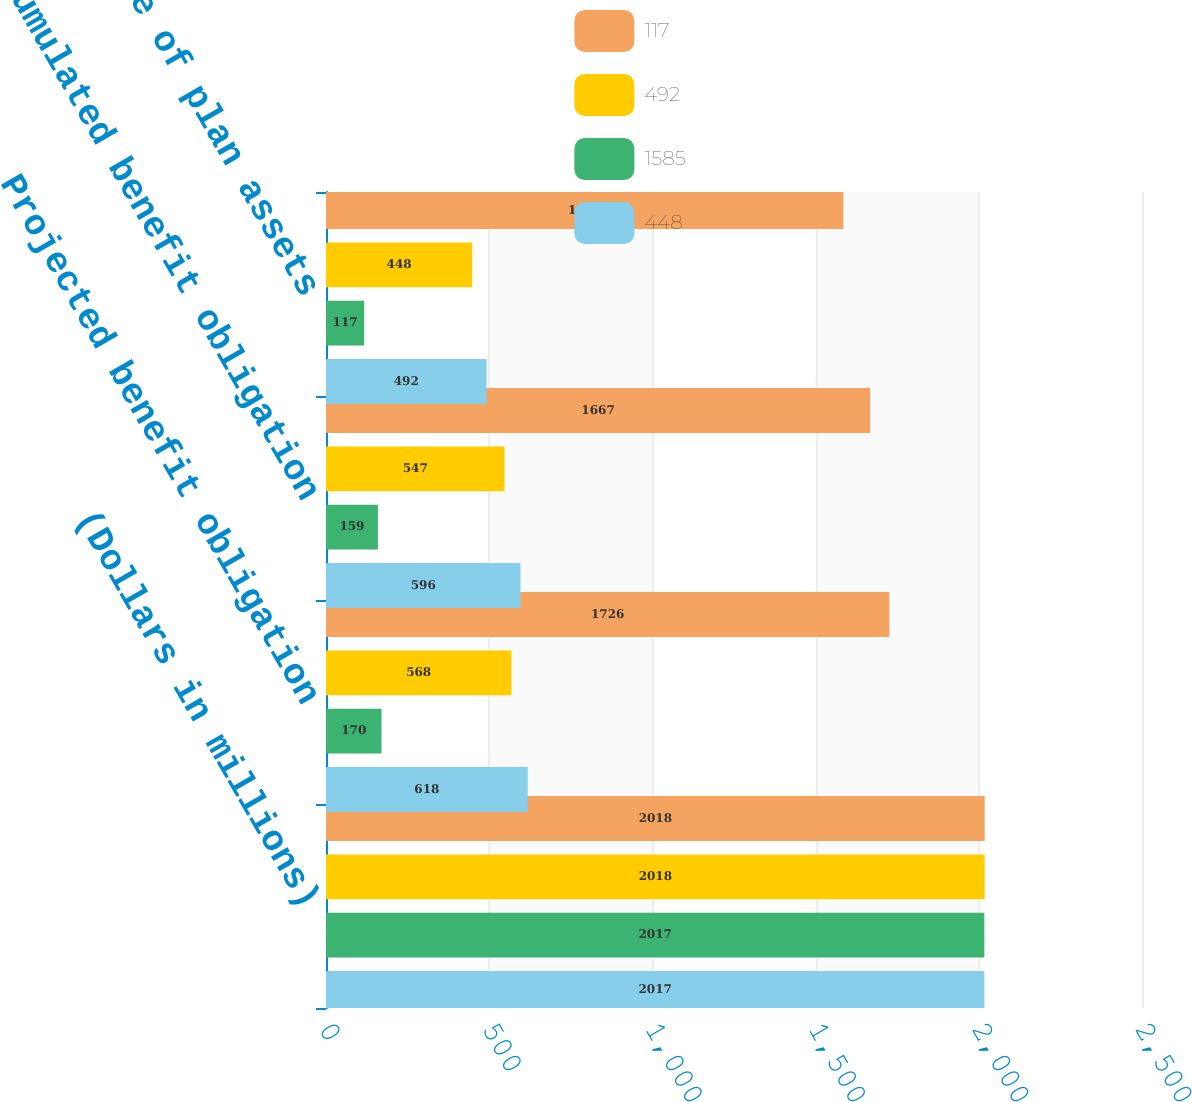Convert chart. <chart><loc_0><loc_0><loc_500><loc_500><stacked_bar_chart><ecel><fcel>(Dollars in millions)<fcel>Projected benefit obligation<fcel>Accumulated benefit obligation<fcel>Fair value of plan assets<nl><fcel>117<fcel>2018<fcel>1726<fcel>1667<fcel>1585<nl><fcel>492<fcel>2018<fcel>568<fcel>547<fcel>448<nl><fcel>1585<fcel>2017<fcel>170<fcel>159<fcel>117<nl><fcel>448<fcel>2017<fcel>618<fcel>596<fcel>492<nl></chart> 